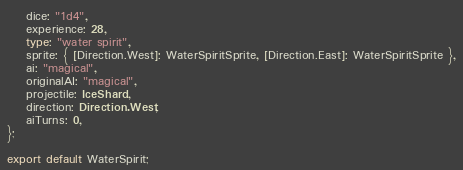Convert code to text. <code><loc_0><loc_0><loc_500><loc_500><_TypeScript_>    dice: "1d4",
    experience: 28,
    type: "water spirit",
    sprite: { [Direction.West]: WaterSpiritSprite, [Direction.East]: WaterSpiritSprite },
    ai: "magical",
    originalAI: "magical",
    projectile: IceShard,
    direction: Direction.West,
    aiTurns: 0,
};

export default WaterSpirit;
</code> 